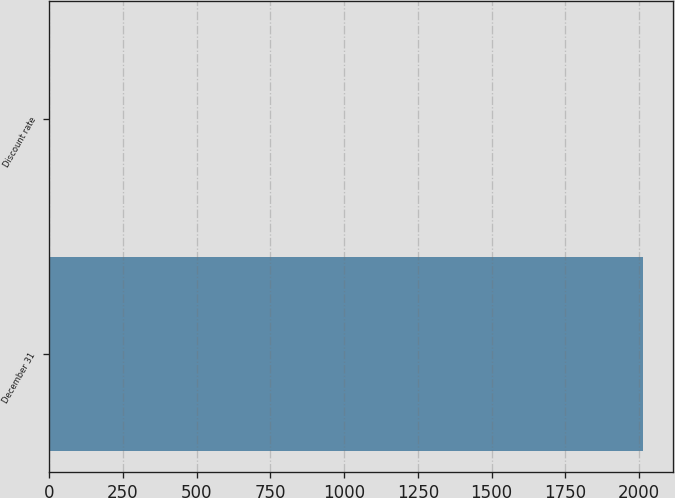Convert chart to OTSL. <chart><loc_0><loc_0><loc_500><loc_500><bar_chart><fcel>December 31<fcel>Discount rate<nl><fcel>2014<fcel>3.75<nl></chart> 